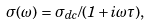<formula> <loc_0><loc_0><loc_500><loc_500>\sigma ( \omega ) = \sigma _ { d c } / ( 1 + i \omega \tau ) ,</formula> 